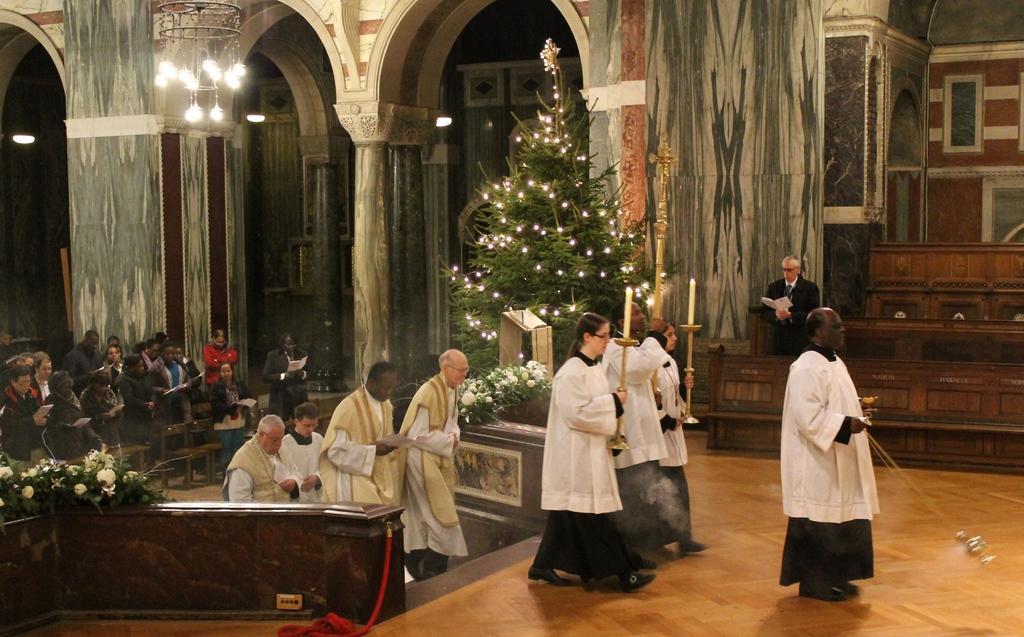Could you give a brief overview of what you see in this image? In the image we can see there are many people standing and walking. They are wearing clothes, shoes and some of them are holding papers and other objects in their hands. Here we can see wooden surface, flowers, trees and lights. Here we can see the pillar and the wall. 